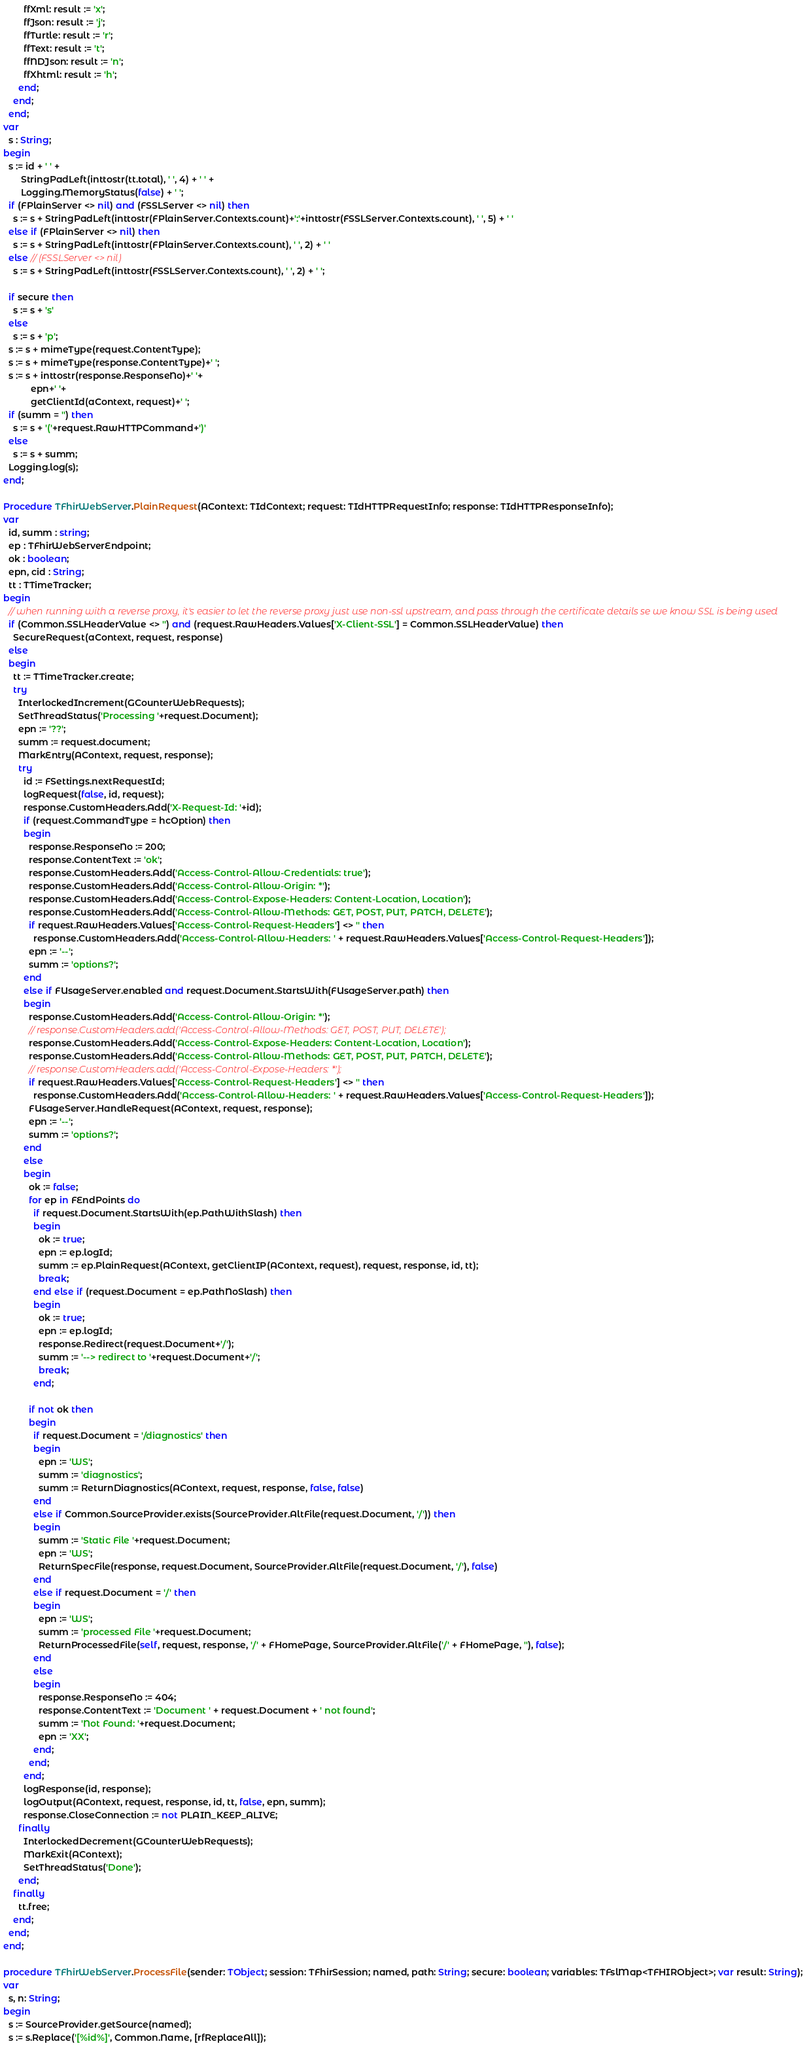Convert code to text. <code><loc_0><loc_0><loc_500><loc_500><_Pascal_>        ffXml: result := 'x';
        ffJson: result := 'j';
        ffTurtle: result := 'r';
        ffText: result := 't';
        ffNDJson: result := 'n';
        ffXhtml: result := 'h';
      end;
    end;
  end;
var
  s : String;
begin
  s := id + ' ' +
       StringPadLeft(inttostr(tt.total), ' ', 4) + ' ' +
       Logging.MemoryStatus(false) + ' ';
  if (FPlainServer <> nil) and (FSSLServer <> nil) then
    s := s + StringPadLeft(inttostr(FPlainServer.Contexts.count)+':'+inttostr(FSSLServer.Contexts.count), ' ', 5) + ' '
  else if (FPlainServer <> nil) then
    s := s + StringPadLeft(inttostr(FPlainServer.Contexts.count), ' ', 2) + ' '
  else // (FSSLServer <> nil)
    s := s + StringPadLeft(inttostr(FSSLServer.Contexts.count), ' ', 2) + ' ';

  if secure then
    s := s + 's'
  else
    s := s + 'p';
  s := s + mimeType(request.ContentType);
  s := s + mimeType(response.ContentType)+' ';
  s := s + inttostr(response.ResponseNo)+' '+
           epn+' '+
           getClientId(aContext, request)+' ';
  if (summ = '') then
    s := s + '('+request.RawHTTPCommand+')'
  else
    s := s + summ;
  Logging.log(s);
end;

Procedure TFhirWebServer.PlainRequest(AContext: TIdContext; request: TIdHTTPRequestInfo; response: TIdHTTPResponseInfo);
var
  id, summ : string;
  ep : TFhirWebServerEndpoint;
  ok : boolean;
  epn, cid : String;
  tt : TTimeTracker;
begin
  // when running with a reverse proxy, it's easier to let the reverse proxy just use non-ssl upstream, and pass through the certificate details se we know SSL is being used
  if (Common.SSLHeaderValue <> '') and (request.RawHeaders.Values['X-Client-SSL'] = Common.SSLHeaderValue) then
    SecureRequest(aContext, request, response)
  else
  begin
    tt := TTimeTracker.create;
    try
      InterlockedIncrement(GCounterWebRequests);
      SetThreadStatus('Processing '+request.Document);
      epn := '??';
      summ := request.document;
      MarkEntry(AContext, request, response);
      try
        id := FSettings.nextRequestId;
        logRequest(false, id, request);
        response.CustomHeaders.Add('X-Request-Id: '+id);
        if (request.CommandType = hcOption) then
        begin
          response.ResponseNo := 200;
          response.ContentText := 'ok';
          response.CustomHeaders.Add('Access-Control-Allow-Credentials: true');
          response.CustomHeaders.Add('Access-Control-Allow-Origin: *');
          response.CustomHeaders.Add('Access-Control-Expose-Headers: Content-Location, Location');
          response.CustomHeaders.Add('Access-Control-Allow-Methods: GET, POST, PUT, PATCH, DELETE');
          if request.RawHeaders.Values['Access-Control-Request-Headers'] <> '' then
            response.CustomHeaders.Add('Access-Control-Allow-Headers: ' + request.RawHeaders.Values['Access-Control-Request-Headers']);
          epn := '--';
          summ := 'options?';
        end
        else if FUsageServer.enabled and request.Document.StartsWith(FUsageServer.path) then
        begin
          response.CustomHeaders.Add('Access-Control-Allow-Origin: *');
          // response.CustomHeaders.add('Access-Control-Allow-Methods: GET, POST, PUT, DELETE');
          response.CustomHeaders.Add('Access-Control-Expose-Headers: Content-Location, Location');
          response.CustomHeaders.Add('Access-Control-Allow-Methods: GET, POST, PUT, PATCH, DELETE');
          // response.CustomHeaders.add('Access-Control-Expose-Headers: *');
          if request.RawHeaders.Values['Access-Control-Request-Headers'] <> '' then
            response.CustomHeaders.Add('Access-Control-Allow-Headers: ' + request.RawHeaders.Values['Access-Control-Request-Headers']);
          FUsageServer.HandleRequest(AContext, request, response);
          epn := '--';
          summ := 'options?';
        end
        else
        begin
          ok := false;
          for ep in FEndPoints do
            if request.Document.StartsWith(ep.PathWithSlash) then
            begin
              ok := true;
              epn := ep.logId;
              summ := ep.PlainRequest(AContext, getClientIP(AContext, request), request, response, id, tt);
              break;
            end else if (request.Document = ep.PathNoSlash) then
            begin
              ok := true;
              epn := ep.logId;
              response.Redirect(request.Document+'/');
              summ := '--> redirect to '+request.Document+'/';
              break;
            end;

          if not ok then
          begin
            if request.Document = '/diagnostics' then
            begin
              epn := 'WS';
              summ := 'diagnostics';
              summ := ReturnDiagnostics(AContext, request, response, false, false)
            end
            else if Common.SourceProvider.exists(SourceProvider.AltFile(request.Document, '/')) then
            begin
              summ := 'Static File '+request.Document;
              epn := 'WS';
              ReturnSpecFile(response, request.Document, SourceProvider.AltFile(request.Document, '/'), false)
            end
            else if request.Document = '/' then
            begin
              epn := 'WS';
              summ := 'processed File '+request.Document;
              ReturnProcessedFile(self, request, response, '/' + FHomePage, SourceProvider.AltFile('/' + FHomePage, ''), false);
            end
            else
            begin
              response.ResponseNo := 404;
              response.ContentText := 'Document ' + request.Document + ' not found';
              summ := 'Not Found: '+request.Document;
              epn := 'XX';
            end;
          end;
        end;
        logResponse(id, response);
        logOutput(AContext, request, response, id, tt, false, epn, summ);
        response.CloseConnection := not PLAIN_KEEP_ALIVE;
      finally
        InterlockedDecrement(GCounterWebRequests);
        MarkExit(AContext);
        SetThreadStatus('Done');
      end;
    finally
      tt.free;
    end;
  end;
end;

procedure TFhirWebServer.ProcessFile(sender: TObject; session: TFhirSession; named, path: String; secure: boolean; variables: TFslMap<TFHIRObject>; var result: String);
var
  s, n: String;
begin
  s := SourceProvider.getSource(named);
  s := s.Replace('[%id%]', Common.Name, [rfReplaceAll]);</code> 